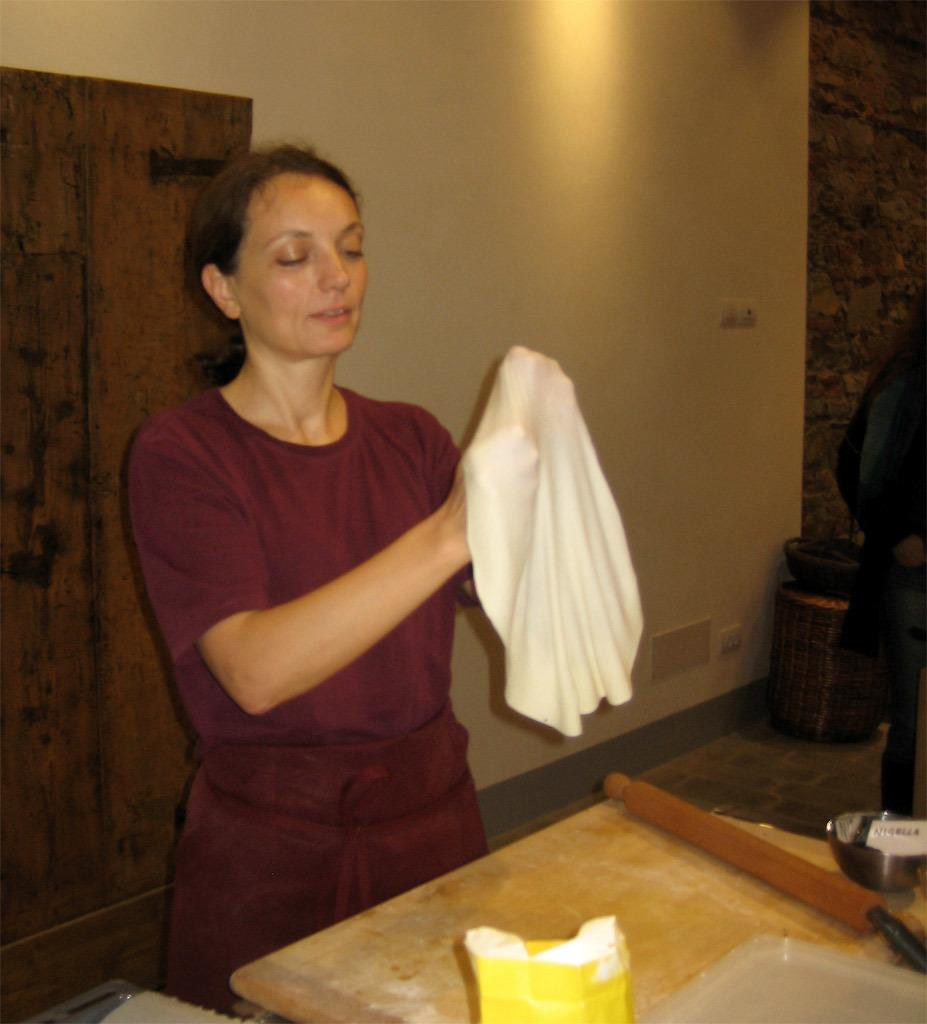Who is present in the image? There is a woman in the image. What is the woman doing in the image? The woman is standing and holding a flattened dough in her hands. What is in front of the woman? There is a wooden surface and a flour packet in front of the woman. What type of vegetable is being discussed by the committee in the image? There is no committee or vegetable present in the image; it features a woman holding a flattened dough. 